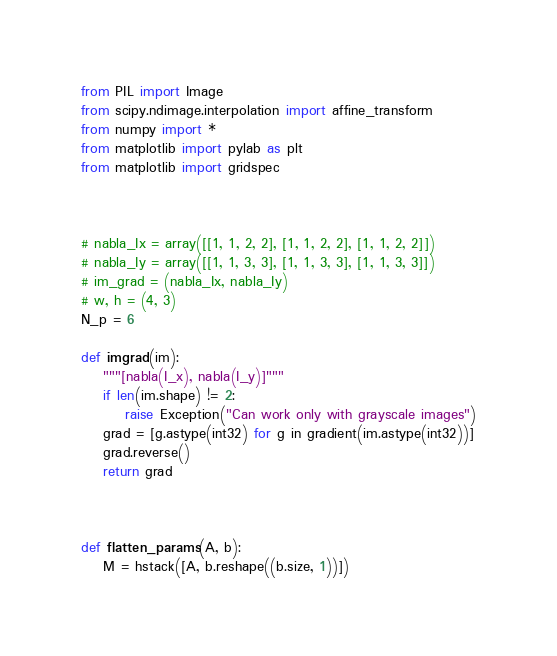Convert code to text. <code><loc_0><loc_0><loc_500><loc_500><_Python_>
from PIL import Image
from scipy.ndimage.interpolation import affine_transform
from numpy import *
from matplotlib import pylab as plt
from matplotlib import gridspec



# nabla_Ix = array([[1, 1, 2, 2], [1, 1, 2, 2], [1, 1, 2, 2]])
# nabla_Iy = array([[1, 1, 3, 3], [1, 1, 3, 3], [1, 1, 3, 3]])
# im_grad = (nabla_Ix, nabla_Iy)
# w, h = (4, 3)
N_p = 6

def imgrad(im):
    """[nabla(I_x), nabla(I_y)]"""
    if len(im.shape) != 2:
        raise Exception("Can work only with grayscale images")
    grad = [g.astype(int32) for g in gradient(im.astype(int32))]
    grad.reverse()
    return grad

    

def flatten_params(A, b):
    M = hstack([A, b.reshape((b.size, 1))])</code> 